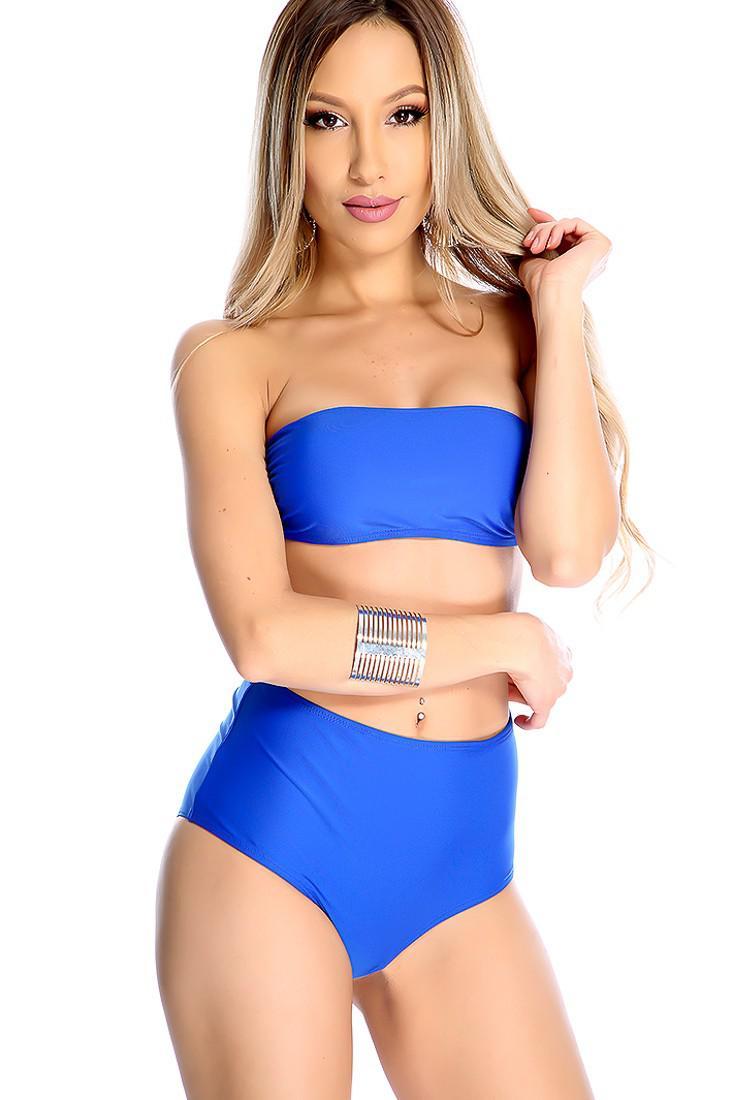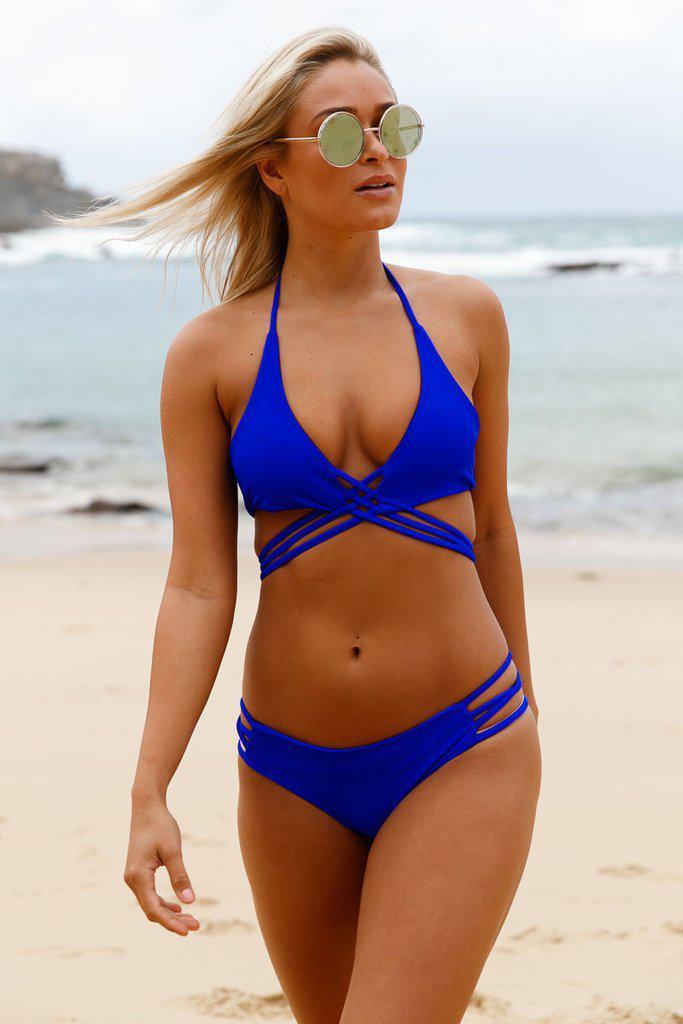The first image is the image on the left, the second image is the image on the right. Examine the images to the left and right. Is the description "In one image, a woman is wearing a necklace." accurate? Answer yes or no. No. 